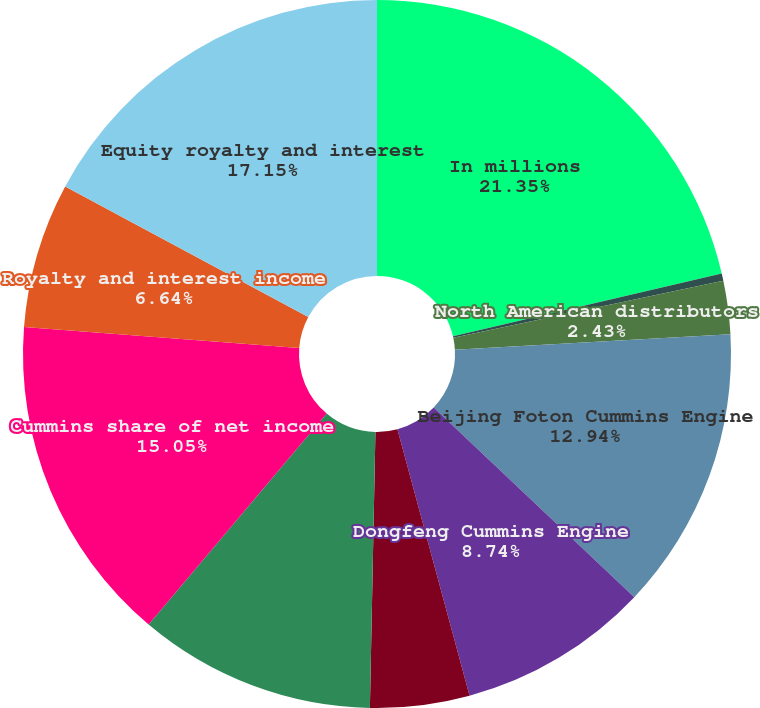Convert chart to OTSL. <chart><loc_0><loc_0><loc_500><loc_500><pie_chart><fcel>In millions<fcel>Komatsu Cummins Chile Ltda<fcel>North American distributors<fcel>Beijing Foton Cummins Engine<fcel>Dongfeng Cummins Engine<fcel>Chongqing Cummins Engine<fcel>All other manufacturers<fcel>Cummins share of net income<fcel>Royalty and interest income<fcel>Equity royalty and interest<nl><fcel>21.35%<fcel>0.33%<fcel>2.43%<fcel>12.94%<fcel>8.74%<fcel>4.53%<fcel>10.84%<fcel>15.05%<fcel>6.64%<fcel>17.15%<nl></chart> 